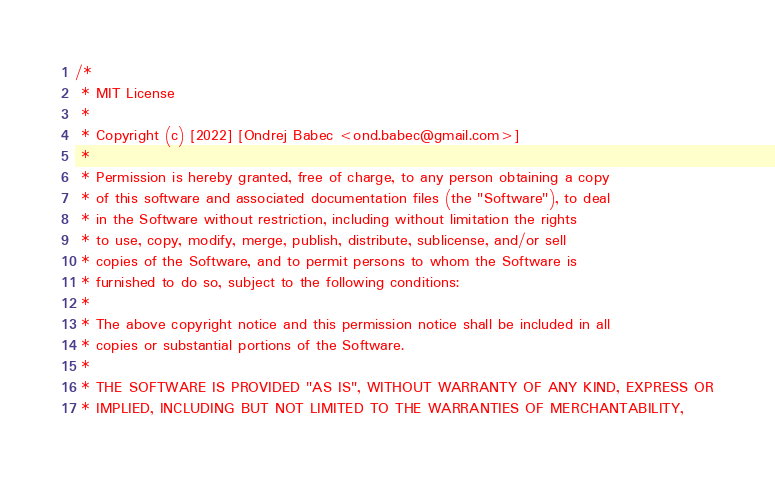<code> <loc_0><loc_0><loc_500><loc_500><_Rust_>/*
 * MIT License
 *
 * Copyright (c) [2022] [Ondrej Babec <ond.babec@gmail.com>]
 *
 * Permission is hereby granted, free of charge, to any person obtaining a copy
 * of this software and associated documentation files (the "Software"), to deal
 * in the Software without restriction, including without limitation the rights
 * to use, copy, modify, merge, publish, distribute, sublicense, and/or sell
 * copies of the Software, and to permit persons to whom the Software is
 * furnished to do so, subject to the following conditions:
 *
 * The above copyright notice and this permission notice shall be included in all
 * copies or substantial portions of the Software.
 *
 * THE SOFTWARE IS PROVIDED "AS IS", WITHOUT WARRANTY OF ANY KIND, EXPRESS OR
 * IMPLIED, INCLUDING BUT NOT LIMITED TO THE WARRANTIES OF MERCHANTABILITY,</code> 